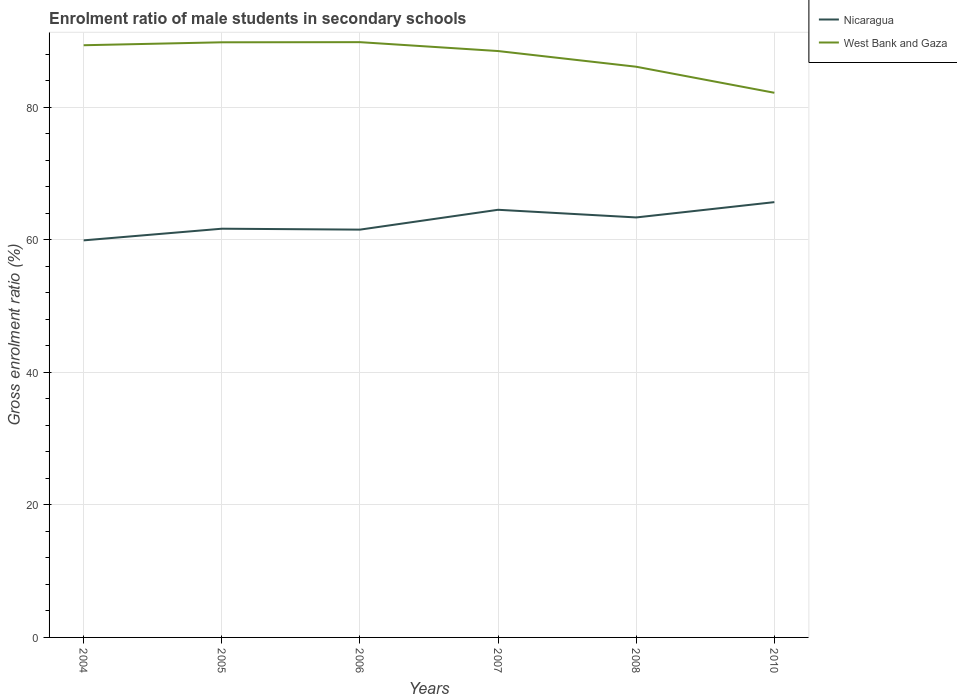How many different coloured lines are there?
Give a very brief answer. 2. Across all years, what is the maximum enrolment ratio of male students in secondary schools in Nicaragua?
Your response must be concise. 59.93. What is the total enrolment ratio of male students in secondary schools in Nicaragua in the graph?
Your answer should be very brief. -4.15. What is the difference between the highest and the second highest enrolment ratio of male students in secondary schools in West Bank and Gaza?
Your answer should be compact. 7.64. Is the enrolment ratio of male students in secondary schools in Nicaragua strictly greater than the enrolment ratio of male students in secondary schools in West Bank and Gaza over the years?
Your response must be concise. Yes. What is the difference between two consecutive major ticks on the Y-axis?
Your response must be concise. 20. Are the values on the major ticks of Y-axis written in scientific E-notation?
Your answer should be very brief. No. Does the graph contain any zero values?
Provide a short and direct response. No. Where does the legend appear in the graph?
Offer a terse response. Top right. How are the legend labels stacked?
Give a very brief answer. Vertical. What is the title of the graph?
Give a very brief answer. Enrolment ratio of male students in secondary schools. What is the label or title of the Y-axis?
Provide a succinct answer. Gross enrolment ratio (%). What is the Gross enrolment ratio (%) in Nicaragua in 2004?
Keep it short and to the point. 59.93. What is the Gross enrolment ratio (%) of West Bank and Gaza in 2004?
Offer a very short reply. 89.38. What is the Gross enrolment ratio (%) in Nicaragua in 2005?
Keep it short and to the point. 61.68. What is the Gross enrolment ratio (%) of West Bank and Gaza in 2005?
Provide a short and direct response. 89.82. What is the Gross enrolment ratio (%) of Nicaragua in 2006?
Provide a short and direct response. 61.55. What is the Gross enrolment ratio (%) of West Bank and Gaza in 2006?
Your answer should be compact. 89.84. What is the Gross enrolment ratio (%) of Nicaragua in 2007?
Your answer should be compact. 64.54. What is the Gross enrolment ratio (%) in West Bank and Gaza in 2007?
Provide a succinct answer. 88.5. What is the Gross enrolment ratio (%) in Nicaragua in 2008?
Ensure brevity in your answer.  63.39. What is the Gross enrolment ratio (%) in West Bank and Gaza in 2008?
Give a very brief answer. 86.13. What is the Gross enrolment ratio (%) of Nicaragua in 2010?
Give a very brief answer. 65.69. What is the Gross enrolment ratio (%) in West Bank and Gaza in 2010?
Your response must be concise. 82.2. Across all years, what is the maximum Gross enrolment ratio (%) of Nicaragua?
Provide a short and direct response. 65.69. Across all years, what is the maximum Gross enrolment ratio (%) in West Bank and Gaza?
Offer a very short reply. 89.84. Across all years, what is the minimum Gross enrolment ratio (%) of Nicaragua?
Give a very brief answer. 59.93. Across all years, what is the minimum Gross enrolment ratio (%) of West Bank and Gaza?
Keep it short and to the point. 82.2. What is the total Gross enrolment ratio (%) in Nicaragua in the graph?
Your answer should be compact. 376.78. What is the total Gross enrolment ratio (%) of West Bank and Gaza in the graph?
Offer a terse response. 525.86. What is the difference between the Gross enrolment ratio (%) of Nicaragua in 2004 and that in 2005?
Ensure brevity in your answer.  -1.76. What is the difference between the Gross enrolment ratio (%) in West Bank and Gaza in 2004 and that in 2005?
Provide a succinct answer. -0.44. What is the difference between the Gross enrolment ratio (%) in Nicaragua in 2004 and that in 2006?
Keep it short and to the point. -1.62. What is the difference between the Gross enrolment ratio (%) of West Bank and Gaza in 2004 and that in 2006?
Your response must be concise. -0.46. What is the difference between the Gross enrolment ratio (%) in Nicaragua in 2004 and that in 2007?
Give a very brief answer. -4.62. What is the difference between the Gross enrolment ratio (%) of West Bank and Gaza in 2004 and that in 2007?
Give a very brief answer. 0.88. What is the difference between the Gross enrolment ratio (%) in Nicaragua in 2004 and that in 2008?
Keep it short and to the point. -3.46. What is the difference between the Gross enrolment ratio (%) of West Bank and Gaza in 2004 and that in 2008?
Your response must be concise. 3.25. What is the difference between the Gross enrolment ratio (%) of Nicaragua in 2004 and that in 2010?
Your answer should be very brief. -5.77. What is the difference between the Gross enrolment ratio (%) in West Bank and Gaza in 2004 and that in 2010?
Offer a very short reply. 7.18. What is the difference between the Gross enrolment ratio (%) in Nicaragua in 2005 and that in 2006?
Ensure brevity in your answer.  0.14. What is the difference between the Gross enrolment ratio (%) in West Bank and Gaza in 2005 and that in 2006?
Your answer should be compact. -0.02. What is the difference between the Gross enrolment ratio (%) in Nicaragua in 2005 and that in 2007?
Your response must be concise. -2.86. What is the difference between the Gross enrolment ratio (%) of West Bank and Gaza in 2005 and that in 2007?
Provide a short and direct response. 1.32. What is the difference between the Gross enrolment ratio (%) in Nicaragua in 2005 and that in 2008?
Your answer should be very brief. -1.7. What is the difference between the Gross enrolment ratio (%) in West Bank and Gaza in 2005 and that in 2008?
Ensure brevity in your answer.  3.69. What is the difference between the Gross enrolment ratio (%) of Nicaragua in 2005 and that in 2010?
Give a very brief answer. -4.01. What is the difference between the Gross enrolment ratio (%) of West Bank and Gaza in 2005 and that in 2010?
Keep it short and to the point. 7.62. What is the difference between the Gross enrolment ratio (%) of Nicaragua in 2006 and that in 2007?
Keep it short and to the point. -3. What is the difference between the Gross enrolment ratio (%) in West Bank and Gaza in 2006 and that in 2007?
Give a very brief answer. 1.34. What is the difference between the Gross enrolment ratio (%) in Nicaragua in 2006 and that in 2008?
Offer a very short reply. -1.84. What is the difference between the Gross enrolment ratio (%) in West Bank and Gaza in 2006 and that in 2008?
Your answer should be compact. 3.71. What is the difference between the Gross enrolment ratio (%) of Nicaragua in 2006 and that in 2010?
Your answer should be compact. -4.15. What is the difference between the Gross enrolment ratio (%) in West Bank and Gaza in 2006 and that in 2010?
Provide a short and direct response. 7.64. What is the difference between the Gross enrolment ratio (%) in Nicaragua in 2007 and that in 2008?
Give a very brief answer. 1.16. What is the difference between the Gross enrolment ratio (%) in West Bank and Gaza in 2007 and that in 2008?
Offer a very short reply. 2.37. What is the difference between the Gross enrolment ratio (%) in Nicaragua in 2007 and that in 2010?
Keep it short and to the point. -1.15. What is the difference between the Gross enrolment ratio (%) in West Bank and Gaza in 2007 and that in 2010?
Ensure brevity in your answer.  6.3. What is the difference between the Gross enrolment ratio (%) in Nicaragua in 2008 and that in 2010?
Provide a short and direct response. -2.31. What is the difference between the Gross enrolment ratio (%) in West Bank and Gaza in 2008 and that in 2010?
Provide a succinct answer. 3.93. What is the difference between the Gross enrolment ratio (%) in Nicaragua in 2004 and the Gross enrolment ratio (%) in West Bank and Gaza in 2005?
Your response must be concise. -29.89. What is the difference between the Gross enrolment ratio (%) of Nicaragua in 2004 and the Gross enrolment ratio (%) of West Bank and Gaza in 2006?
Provide a succinct answer. -29.91. What is the difference between the Gross enrolment ratio (%) of Nicaragua in 2004 and the Gross enrolment ratio (%) of West Bank and Gaza in 2007?
Provide a succinct answer. -28.57. What is the difference between the Gross enrolment ratio (%) in Nicaragua in 2004 and the Gross enrolment ratio (%) in West Bank and Gaza in 2008?
Your answer should be very brief. -26.2. What is the difference between the Gross enrolment ratio (%) in Nicaragua in 2004 and the Gross enrolment ratio (%) in West Bank and Gaza in 2010?
Provide a short and direct response. -22.27. What is the difference between the Gross enrolment ratio (%) of Nicaragua in 2005 and the Gross enrolment ratio (%) of West Bank and Gaza in 2006?
Give a very brief answer. -28.15. What is the difference between the Gross enrolment ratio (%) in Nicaragua in 2005 and the Gross enrolment ratio (%) in West Bank and Gaza in 2007?
Your response must be concise. -26.81. What is the difference between the Gross enrolment ratio (%) of Nicaragua in 2005 and the Gross enrolment ratio (%) of West Bank and Gaza in 2008?
Your answer should be compact. -24.45. What is the difference between the Gross enrolment ratio (%) of Nicaragua in 2005 and the Gross enrolment ratio (%) of West Bank and Gaza in 2010?
Your answer should be very brief. -20.51. What is the difference between the Gross enrolment ratio (%) in Nicaragua in 2006 and the Gross enrolment ratio (%) in West Bank and Gaza in 2007?
Your answer should be very brief. -26.95. What is the difference between the Gross enrolment ratio (%) in Nicaragua in 2006 and the Gross enrolment ratio (%) in West Bank and Gaza in 2008?
Offer a terse response. -24.58. What is the difference between the Gross enrolment ratio (%) in Nicaragua in 2006 and the Gross enrolment ratio (%) in West Bank and Gaza in 2010?
Provide a succinct answer. -20.65. What is the difference between the Gross enrolment ratio (%) of Nicaragua in 2007 and the Gross enrolment ratio (%) of West Bank and Gaza in 2008?
Keep it short and to the point. -21.59. What is the difference between the Gross enrolment ratio (%) of Nicaragua in 2007 and the Gross enrolment ratio (%) of West Bank and Gaza in 2010?
Your answer should be very brief. -17.66. What is the difference between the Gross enrolment ratio (%) in Nicaragua in 2008 and the Gross enrolment ratio (%) in West Bank and Gaza in 2010?
Provide a short and direct response. -18.81. What is the average Gross enrolment ratio (%) in Nicaragua per year?
Your response must be concise. 62.8. What is the average Gross enrolment ratio (%) in West Bank and Gaza per year?
Provide a short and direct response. 87.64. In the year 2004, what is the difference between the Gross enrolment ratio (%) of Nicaragua and Gross enrolment ratio (%) of West Bank and Gaza?
Offer a terse response. -29.45. In the year 2005, what is the difference between the Gross enrolment ratio (%) of Nicaragua and Gross enrolment ratio (%) of West Bank and Gaza?
Your answer should be very brief. -28.13. In the year 2006, what is the difference between the Gross enrolment ratio (%) in Nicaragua and Gross enrolment ratio (%) in West Bank and Gaza?
Offer a terse response. -28.29. In the year 2007, what is the difference between the Gross enrolment ratio (%) in Nicaragua and Gross enrolment ratio (%) in West Bank and Gaza?
Provide a succinct answer. -23.96. In the year 2008, what is the difference between the Gross enrolment ratio (%) in Nicaragua and Gross enrolment ratio (%) in West Bank and Gaza?
Offer a very short reply. -22.74. In the year 2010, what is the difference between the Gross enrolment ratio (%) in Nicaragua and Gross enrolment ratio (%) in West Bank and Gaza?
Offer a very short reply. -16.5. What is the ratio of the Gross enrolment ratio (%) of Nicaragua in 2004 to that in 2005?
Keep it short and to the point. 0.97. What is the ratio of the Gross enrolment ratio (%) of West Bank and Gaza in 2004 to that in 2005?
Your answer should be compact. 1. What is the ratio of the Gross enrolment ratio (%) in Nicaragua in 2004 to that in 2006?
Offer a very short reply. 0.97. What is the ratio of the Gross enrolment ratio (%) in Nicaragua in 2004 to that in 2007?
Make the answer very short. 0.93. What is the ratio of the Gross enrolment ratio (%) of West Bank and Gaza in 2004 to that in 2007?
Provide a short and direct response. 1.01. What is the ratio of the Gross enrolment ratio (%) in Nicaragua in 2004 to that in 2008?
Ensure brevity in your answer.  0.95. What is the ratio of the Gross enrolment ratio (%) of West Bank and Gaza in 2004 to that in 2008?
Provide a succinct answer. 1.04. What is the ratio of the Gross enrolment ratio (%) in Nicaragua in 2004 to that in 2010?
Your answer should be very brief. 0.91. What is the ratio of the Gross enrolment ratio (%) in West Bank and Gaza in 2004 to that in 2010?
Offer a very short reply. 1.09. What is the ratio of the Gross enrolment ratio (%) of West Bank and Gaza in 2005 to that in 2006?
Your answer should be very brief. 1. What is the ratio of the Gross enrolment ratio (%) in Nicaragua in 2005 to that in 2007?
Keep it short and to the point. 0.96. What is the ratio of the Gross enrolment ratio (%) in West Bank and Gaza in 2005 to that in 2007?
Offer a terse response. 1.01. What is the ratio of the Gross enrolment ratio (%) of Nicaragua in 2005 to that in 2008?
Keep it short and to the point. 0.97. What is the ratio of the Gross enrolment ratio (%) of West Bank and Gaza in 2005 to that in 2008?
Your answer should be very brief. 1.04. What is the ratio of the Gross enrolment ratio (%) in Nicaragua in 2005 to that in 2010?
Provide a short and direct response. 0.94. What is the ratio of the Gross enrolment ratio (%) in West Bank and Gaza in 2005 to that in 2010?
Offer a terse response. 1.09. What is the ratio of the Gross enrolment ratio (%) in Nicaragua in 2006 to that in 2007?
Ensure brevity in your answer.  0.95. What is the ratio of the Gross enrolment ratio (%) in West Bank and Gaza in 2006 to that in 2007?
Provide a succinct answer. 1.02. What is the ratio of the Gross enrolment ratio (%) in Nicaragua in 2006 to that in 2008?
Your answer should be compact. 0.97. What is the ratio of the Gross enrolment ratio (%) of West Bank and Gaza in 2006 to that in 2008?
Offer a very short reply. 1.04. What is the ratio of the Gross enrolment ratio (%) of Nicaragua in 2006 to that in 2010?
Your answer should be compact. 0.94. What is the ratio of the Gross enrolment ratio (%) in West Bank and Gaza in 2006 to that in 2010?
Offer a terse response. 1.09. What is the ratio of the Gross enrolment ratio (%) in Nicaragua in 2007 to that in 2008?
Provide a short and direct response. 1.02. What is the ratio of the Gross enrolment ratio (%) in West Bank and Gaza in 2007 to that in 2008?
Ensure brevity in your answer.  1.03. What is the ratio of the Gross enrolment ratio (%) of Nicaragua in 2007 to that in 2010?
Provide a succinct answer. 0.98. What is the ratio of the Gross enrolment ratio (%) of West Bank and Gaza in 2007 to that in 2010?
Offer a terse response. 1.08. What is the ratio of the Gross enrolment ratio (%) of Nicaragua in 2008 to that in 2010?
Give a very brief answer. 0.96. What is the ratio of the Gross enrolment ratio (%) in West Bank and Gaza in 2008 to that in 2010?
Provide a succinct answer. 1.05. What is the difference between the highest and the second highest Gross enrolment ratio (%) of Nicaragua?
Offer a very short reply. 1.15. What is the difference between the highest and the second highest Gross enrolment ratio (%) of West Bank and Gaza?
Give a very brief answer. 0.02. What is the difference between the highest and the lowest Gross enrolment ratio (%) in Nicaragua?
Offer a terse response. 5.77. What is the difference between the highest and the lowest Gross enrolment ratio (%) of West Bank and Gaza?
Offer a very short reply. 7.64. 